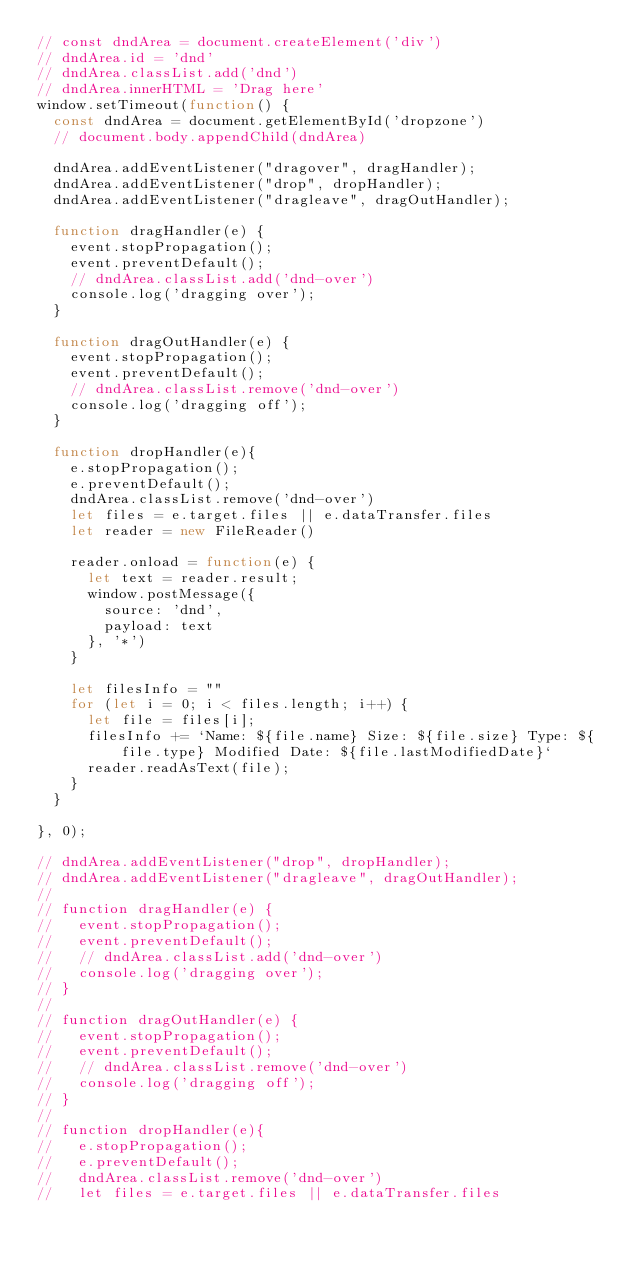Convert code to text. <code><loc_0><loc_0><loc_500><loc_500><_JavaScript_>// const dndArea = document.createElement('div')
// dndArea.id = 'dnd'
// dndArea.classList.add('dnd')
// dndArea.innerHTML = 'Drag here'
window.setTimeout(function() {
  const dndArea = document.getElementById('dropzone')
  // document.body.appendChild(dndArea)

  dndArea.addEventListener("dragover", dragHandler);
  dndArea.addEventListener("drop", dropHandler);
  dndArea.addEventListener("dragleave", dragOutHandler);

  function dragHandler(e) {
    event.stopPropagation();
    event.preventDefault();
    // dndArea.classList.add('dnd-over')
    console.log('dragging over');
  }

  function dragOutHandler(e) {
    event.stopPropagation();
    event.preventDefault();
    // dndArea.classList.remove('dnd-over')
    console.log('dragging off');
  }

  function dropHandler(e){
    e.stopPropagation();
    e.preventDefault();
    dndArea.classList.remove('dnd-over')
    let files = e.target.files || e.dataTransfer.files
    let reader = new FileReader()

    reader.onload = function(e) {
      let text = reader.result;
      window.postMessage({
        source: 'dnd',
        payload: text
      }, '*')
    }

    let filesInfo = ""
    for (let i = 0; i < files.length; i++) {
      let file = files[i];
      filesInfo += `Name: ${file.name} Size: ${file.size} Type: ${file.type} Modified Date: ${file.lastModifiedDate}`
      reader.readAsText(file);
    }
  }

}, 0);

// dndArea.addEventListener("drop", dropHandler);
// dndArea.addEventListener("dragleave", dragOutHandler);
//
// function dragHandler(e) {
//   event.stopPropagation();
//   event.preventDefault();
//   // dndArea.classList.add('dnd-over')
//   console.log('dragging over');
// }
//
// function dragOutHandler(e) {
//   event.stopPropagation();
//   event.preventDefault();
//   // dndArea.classList.remove('dnd-over')
//   console.log('dragging off');
// }
//
// function dropHandler(e){
//   e.stopPropagation();
//   e.preventDefault();
//   dndArea.classList.remove('dnd-over')
//   let files = e.target.files || e.dataTransfer.files</code> 